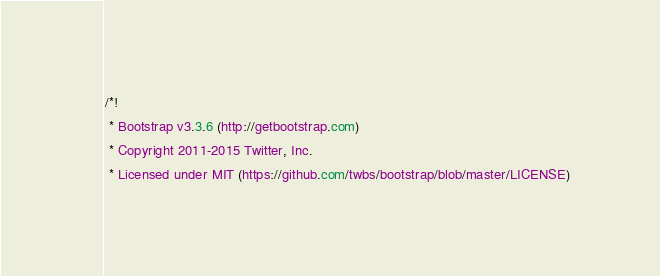<code> <loc_0><loc_0><loc_500><loc_500><_CSS_>/*!
 * Bootstrap v3.3.6 (http://getbootstrap.com)
 * Copyright 2011-2015 Twitter, Inc.
 * Licensed under MIT (https://github.com/twbs/bootstrap/blob/master/LICENSE)</code> 